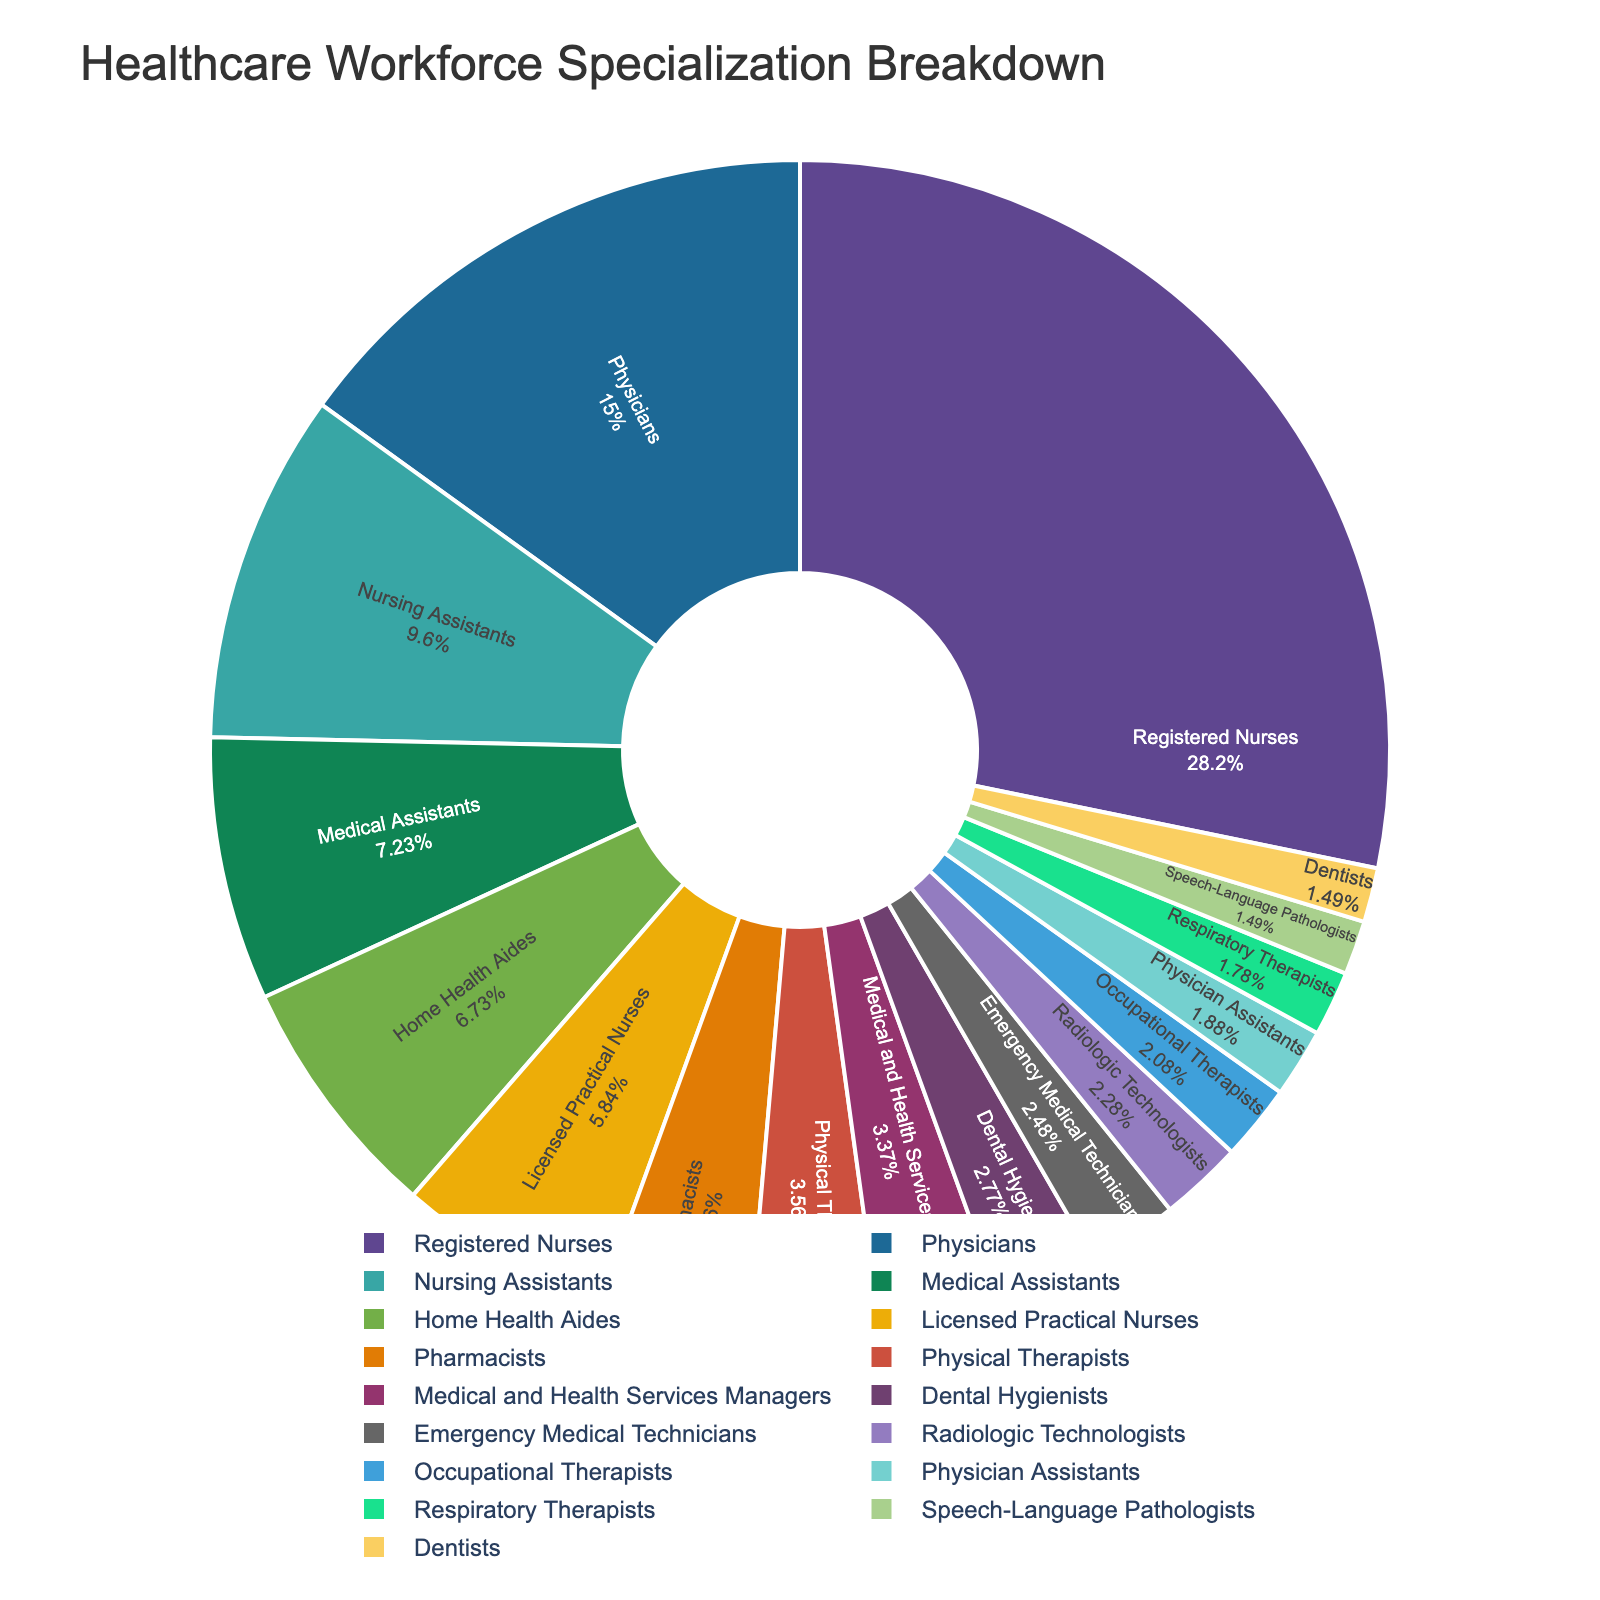What's the largest specialization in the healthcare workforce? The largest sector can be identified by looking for the segment with the highest percentage in the pie chart. In this chart, Registered Nurses have the highest percentage.
Answer: Registered Nurses Which specialization has a larger percentage, Physicians or Physical Therapists? To compare their proportions, locate both sectors in the pie chart. Physicians have a 15.2% share, while Physical Therapists have a 3.6% share.
Answer: Physicians Which three specializations have the smallest percentages in the workforce? By examining the chart's segments with the smallest percentages, you can identify the three smallest sectors. They are Speech-Language Pathologists (1.5%), Dentists (1.5%), and Respiratory Therapists (1.8%).
Answer: Speech-Language Pathologists, Dentists, Respiratory Therapists How much more prominent is the largest group compared to the smallest group? Locate the largest group (Registered Nurses, 28.5%) and the smallest group (Speech-Language Pathologists and Dentists, both 1.5%). Calculate the difference: 28.5% - 1.5% = 27%.
Answer: 27% What percentage of the workforce is comprised of Nurses (Registered Nurses, Nursing Assistants, and Licensed Practical Nurses)? Sum the percentages of the specified categories: 28.5% (Registered Nurses) + 9.7% (Nursing Assistants) + 5.9% (Licensed Practical Nurses) = 44.1%.
Answer: 44.1% Are there more Medical Assistants or Dental Hygienists in the workforce? Compare the percentages of both groups: Medical Assistants have 7.3%, while Dental Hygienists have 2.8%.
Answer: Medical Assistants Which specialization makes up just over 2% of the workforce? Look for a segment that's slightly above 2%: Radiologic Technologists have a 2.3% share.
Answer: Radiologic Technologists What's the combined percentage of Emergency Medical Technicians and Physician Assistants? Add the percentages of both groups: Emergency Medical Technicians (2.5%) + Physician Assistants (1.9%) = 4.4%.
Answer: 4.4% What is the difference in percentage between Physicians and Nursing Assistants? Subtract Nursing Assistants' percentage from Physicians': 15.2% - 9.7% = 5.5%.
Answer: 5.5% Which specialization appears just above Pharmacists in terms of workforce percentage? Identify the category listed just above the 4.2% for Pharmacists: Licensed Practical Nurses with 5.9%.
Answer: Licensed Practical Nurses 